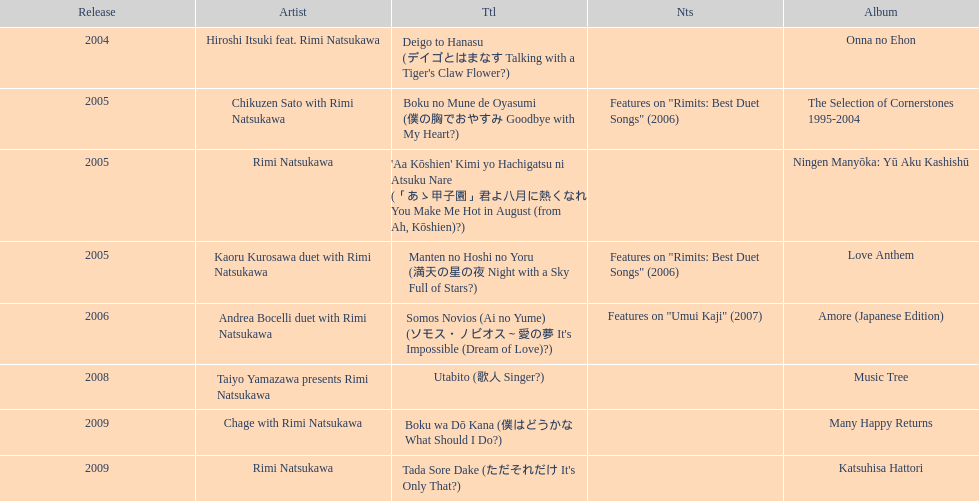What has been the last song this artist has made an other appearance on? Tada Sore Dake. 